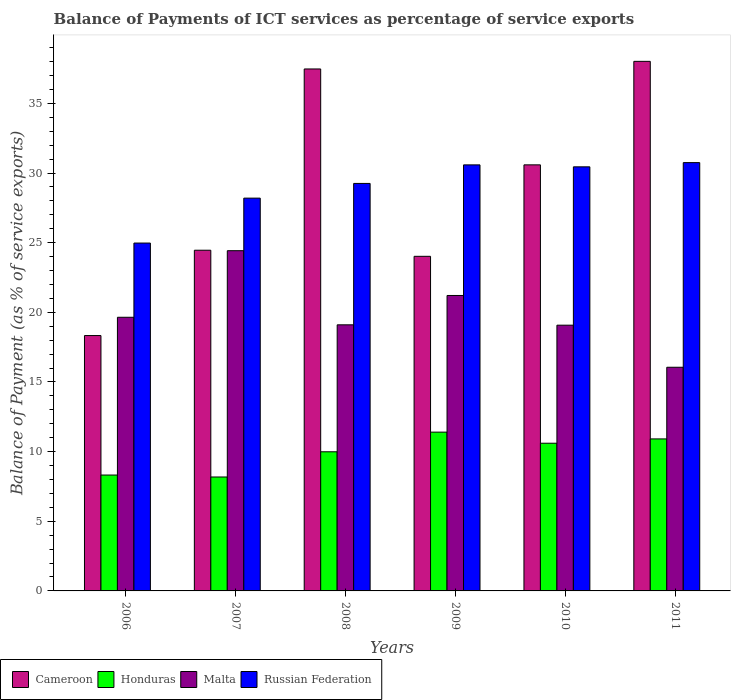How many different coloured bars are there?
Ensure brevity in your answer.  4. How many groups of bars are there?
Your answer should be compact. 6. Are the number of bars per tick equal to the number of legend labels?
Ensure brevity in your answer.  Yes. Are the number of bars on each tick of the X-axis equal?
Keep it short and to the point. Yes. How many bars are there on the 5th tick from the left?
Provide a short and direct response. 4. What is the label of the 1st group of bars from the left?
Make the answer very short. 2006. In how many cases, is the number of bars for a given year not equal to the number of legend labels?
Your answer should be very brief. 0. What is the balance of payments of ICT services in Malta in 2010?
Provide a short and direct response. 19.08. Across all years, what is the maximum balance of payments of ICT services in Cameroon?
Keep it short and to the point. 38.01. Across all years, what is the minimum balance of payments of ICT services in Honduras?
Keep it short and to the point. 8.18. In which year was the balance of payments of ICT services in Russian Federation maximum?
Your response must be concise. 2011. In which year was the balance of payments of ICT services in Malta minimum?
Give a very brief answer. 2011. What is the total balance of payments of ICT services in Malta in the graph?
Offer a terse response. 119.51. What is the difference between the balance of payments of ICT services in Honduras in 2006 and that in 2007?
Your answer should be compact. 0.14. What is the difference between the balance of payments of ICT services in Cameroon in 2011 and the balance of payments of ICT services in Russian Federation in 2009?
Provide a succinct answer. 7.43. What is the average balance of payments of ICT services in Russian Federation per year?
Provide a short and direct response. 29.03. In the year 2011, what is the difference between the balance of payments of ICT services in Malta and balance of payments of ICT services in Russian Federation?
Your response must be concise. -14.69. What is the ratio of the balance of payments of ICT services in Cameroon in 2009 to that in 2011?
Offer a terse response. 0.63. What is the difference between the highest and the second highest balance of payments of ICT services in Cameroon?
Your response must be concise. 0.55. What is the difference between the highest and the lowest balance of payments of ICT services in Honduras?
Give a very brief answer. 3.22. Is the sum of the balance of payments of ICT services in Russian Federation in 2007 and 2011 greater than the maximum balance of payments of ICT services in Honduras across all years?
Give a very brief answer. Yes. What does the 4th bar from the left in 2006 represents?
Your answer should be compact. Russian Federation. What does the 2nd bar from the right in 2008 represents?
Make the answer very short. Malta. Is it the case that in every year, the sum of the balance of payments of ICT services in Russian Federation and balance of payments of ICT services in Malta is greater than the balance of payments of ICT services in Honduras?
Offer a very short reply. Yes. How many bars are there?
Ensure brevity in your answer.  24. Are all the bars in the graph horizontal?
Your answer should be very brief. No. How many years are there in the graph?
Keep it short and to the point. 6. Does the graph contain any zero values?
Provide a short and direct response. No. How many legend labels are there?
Ensure brevity in your answer.  4. How are the legend labels stacked?
Provide a short and direct response. Horizontal. What is the title of the graph?
Provide a short and direct response. Balance of Payments of ICT services as percentage of service exports. Does "Timor-Leste" appear as one of the legend labels in the graph?
Ensure brevity in your answer.  No. What is the label or title of the X-axis?
Offer a terse response. Years. What is the label or title of the Y-axis?
Your answer should be compact. Balance of Payment (as % of service exports). What is the Balance of Payment (as % of service exports) in Cameroon in 2006?
Keep it short and to the point. 18.33. What is the Balance of Payment (as % of service exports) in Honduras in 2006?
Your answer should be compact. 8.32. What is the Balance of Payment (as % of service exports) in Malta in 2006?
Provide a succinct answer. 19.64. What is the Balance of Payment (as % of service exports) of Russian Federation in 2006?
Your response must be concise. 24.97. What is the Balance of Payment (as % of service exports) in Cameroon in 2007?
Offer a terse response. 24.46. What is the Balance of Payment (as % of service exports) in Honduras in 2007?
Your answer should be very brief. 8.18. What is the Balance of Payment (as % of service exports) of Malta in 2007?
Your answer should be compact. 24.42. What is the Balance of Payment (as % of service exports) of Russian Federation in 2007?
Provide a succinct answer. 28.2. What is the Balance of Payment (as % of service exports) in Cameroon in 2008?
Provide a succinct answer. 37.47. What is the Balance of Payment (as % of service exports) of Honduras in 2008?
Provide a succinct answer. 9.99. What is the Balance of Payment (as % of service exports) in Malta in 2008?
Give a very brief answer. 19.1. What is the Balance of Payment (as % of service exports) of Russian Federation in 2008?
Keep it short and to the point. 29.25. What is the Balance of Payment (as % of service exports) of Cameroon in 2009?
Offer a very short reply. 24.02. What is the Balance of Payment (as % of service exports) of Honduras in 2009?
Ensure brevity in your answer.  11.4. What is the Balance of Payment (as % of service exports) of Malta in 2009?
Your answer should be compact. 21.21. What is the Balance of Payment (as % of service exports) of Russian Federation in 2009?
Your answer should be compact. 30.58. What is the Balance of Payment (as % of service exports) of Cameroon in 2010?
Ensure brevity in your answer.  30.58. What is the Balance of Payment (as % of service exports) in Honduras in 2010?
Offer a terse response. 10.6. What is the Balance of Payment (as % of service exports) of Malta in 2010?
Ensure brevity in your answer.  19.08. What is the Balance of Payment (as % of service exports) in Russian Federation in 2010?
Offer a very short reply. 30.44. What is the Balance of Payment (as % of service exports) of Cameroon in 2011?
Provide a succinct answer. 38.01. What is the Balance of Payment (as % of service exports) in Honduras in 2011?
Offer a terse response. 10.91. What is the Balance of Payment (as % of service exports) in Malta in 2011?
Offer a very short reply. 16.06. What is the Balance of Payment (as % of service exports) of Russian Federation in 2011?
Your answer should be very brief. 30.74. Across all years, what is the maximum Balance of Payment (as % of service exports) of Cameroon?
Provide a short and direct response. 38.01. Across all years, what is the maximum Balance of Payment (as % of service exports) in Honduras?
Offer a terse response. 11.4. Across all years, what is the maximum Balance of Payment (as % of service exports) in Malta?
Provide a succinct answer. 24.42. Across all years, what is the maximum Balance of Payment (as % of service exports) in Russian Federation?
Your response must be concise. 30.74. Across all years, what is the minimum Balance of Payment (as % of service exports) of Cameroon?
Your response must be concise. 18.33. Across all years, what is the minimum Balance of Payment (as % of service exports) in Honduras?
Ensure brevity in your answer.  8.18. Across all years, what is the minimum Balance of Payment (as % of service exports) of Malta?
Your answer should be very brief. 16.06. Across all years, what is the minimum Balance of Payment (as % of service exports) in Russian Federation?
Your answer should be compact. 24.97. What is the total Balance of Payment (as % of service exports) of Cameroon in the graph?
Provide a short and direct response. 172.87. What is the total Balance of Payment (as % of service exports) in Honduras in the graph?
Make the answer very short. 59.4. What is the total Balance of Payment (as % of service exports) in Malta in the graph?
Your answer should be compact. 119.51. What is the total Balance of Payment (as % of service exports) of Russian Federation in the graph?
Give a very brief answer. 174.19. What is the difference between the Balance of Payment (as % of service exports) of Cameroon in 2006 and that in 2007?
Provide a short and direct response. -6.13. What is the difference between the Balance of Payment (as % of service exports) of Honduras in 2006 and that in 2007?
Provide a succinct answer. 0.14. What is the difference between the Balance of Payment (as % of service exports) of Malta in 2006 and that in 2007?
Your response must be concise. -4.78. What is the difference between the Balance of Payment (as % of service exports) of Russian Federation in 2006 and that in 2007?
Make the answer very short. -3.23. What is the difference between the Balance of Payment (as % of service exports) in Cameroon in 2006 and that in 2008?
Your answer should be very brief. -19.14. What is the difference between the Balance of Payment (as % of service exports) of Honduras in 2006 and that in 2008?
Offer a very short reply. -1.67. What is the difference between the Balance of Payment (as % of service exports) of Malta in 2006 and that in 2008?
Your response must be concise. 0.54. What is the difference between the Balance of Payment (as % of service exports) of Russian Federation in 2006 and that in 2008?
Give a very brief answer. -4.28. What is the difference between the Balance of Payment (as % of service exports) in Cameroon in 2006 and that in 2009?
Offer a terse response. -5.69. What is the difference between the Balance of Payment (as % of service exports) of Honduras in 2006 and that in 2009?
Your response must be concise. -3.08. What is the difference between the Balance of Payment (as % of service exports) of Malta in 2006 and that in 2009?
Offer a terse response. -1.56. What is the difference between the Balance of Payment (as % of service exports) in Russian Federation in 2006 and that in 2009?
Provide a short and direct response. -5.61. What is the difference between the Balance of Payment (as % of service exports) in Cameroon in 2006 and that in 2010?
Offer a very short reply. -12.25. What is the difference between the Balance of Payment (as % of service exports) in Honduras in 2006 and that in 2010?
Offer a very short reply. -2.28. What is the difference between the Balance of Payment (as % of service exports) of Malta in 2006 and that in 2010?
Give a very brief answer. 0.57. What is the difference between the Balance of Payment (as % of service exports) in Russian Federation in 2006 and that in 2010?
Offer a very short reply. -5.47. What is the difference between the Balance of Payment (as % of service exports) of Cameroon in 2006 and that in 2011?
Give a very brief answer. -19.68. What is the difference between the Balance of Payment (as % of service exports) of Honduras in 2006 and that in 2011?
Offer a terse response. -2.59. What is the difference between the Balance of Payment (as % of service exports) of Malta in 2006 and that in 2011?
Keep it short and to the point. 3.59. What is the difference between the Balance of Payment (as % of service exports) of Russian Federation in 2006 and that in 2011?
Offer a terse response. -5.77. What is the difference between the Balance of Payment (as % of service exports) in Cameroon in 2007 and that in 2008?
Give a very brief answer. -13.01. What is the difference between the Balance of Payment (as % of service exports) of Honduras in 2007 and that in 2008?
Provide a succinct answer. -1.81. What is the difference between the Balance of Payment (as % of service exports) in Malta in 2007 and that in 2008?
Your response must be concise. 5.32. What is the difference between the Balance of Payment (as % of service exports) of Russian Federation in 2007 and that in 2008?
Provide a succinct answer. -1.06. What is the difference between the Balance of Payment (as % of service exports) in Cameroon in 2007 and that in 2009?
Your answer should be very brief. 0.44. What is the difference between the Balance of Payment (as % of service exports) of Honduras in 2007 and that in 2009?
Offer a terse response. -3.22. What is the difference between the Balance of Payment (as % of service exports) of Malta in 2007 and that in 2009?
Your answer should be compact. 3.21. What is the difference between the Balance of Payment (as % of service exports) in Russian Federation in 2007 and that in 2009?
Your response must be concise. -2.39. What is the difference between the Balance of Payment (as % of service exports) in Cameroon in 2007 and that in 2010?
Ensure brevity in your answer.  -6.13. What is the difference between the Balance of Payment (as % of service exports) in Honduras in 2007 and that in 2010?
Make the answer very short. -2.42. What is the difference between the Balance of Payment (as % of service exports) of Malta in 2007 and that in 2010?
Your answer should be compact. 5.35. What is the difference between the Balance of Payment (as % of service exports) in Russian Federation in 2007 and that in 2010?
Provide a short and direct response. -2.25. What is the difference between the Balance of Payment (as % of service exports) of Cameroon in 2007 and that in 2011?
Your response must be concise. -13.56. What is the difference between the Balance of Payment (as % of service exports) in Honduras in 2007 and that in 2011?
Your response must be concise. -2.73. What is the difference between the Balance of Payment (as % of service exports) in Malta in 2007 and that in 2011?
Your answer should be compact. 8.37. What is the difference between the Balance of Payment (as % of service exports) in Russian Federation in 2007 and that in 2011?
Ensure brevity in your answer.  -2.55. What is the difference between the Balance of Payment (as % of service exports) of Cameroon in 2008 and that in 2009?
Keep it short and to the point. 13.45. What is the difference between the Balance of Payment (as % of service exports) in Honduras in 2008 and that in 2009?
Your answer should be very brief. -1.41. What is the difference between the Balance of Payment (as % of service exports) of Malta in 2008 and that in 2009?
Provide a succinct answer. -2.11. What is the difference between the Balance of Payment (as % of service exports) in Russian Federation in 2008 and that in 2009?
Provide a succinct answer. -1.33. What is the difference between the Balance of Payment (as % of service exports) in Cameroon in 2008 and that in 2010?
Your response must be concise. 6.88. What is the difference between the Balance of Payment (as % of service exports) of Honduras in 2008 and that in 2010?
Ensure brevity in your answer.  -0.61. What is the difference between the Balance of Payment (as % of service exports) in Malta in 2008 and that in 2010?
Provide a short and direct response. 0.03. What is the difference between the Balance of Payment (as % of service exports) of Russian Federation in 2008 and that in 2010?
Your answer should be compact. -1.19. What is the difference between the Balance of Payment (as % of service exports) in Cameroon in 2008 and that in 2011?
Your answer should be very brief. -0.55. What is the difference between the Balance of Payment (as % of service exports) of Honduras in 2008 and that in 2011?
Keep it short and to the point. -0.92. What is the difference between the Balance of Payment (as % of service exports) in Malta in 2008 and that in 2011?
Offer a very short reply. 3.05. What is the difference between the Balance of Payment (as % of service exports) in Russian Federation in 2008 and that in 2011?
Provide a short and direct response. -1.49. What is the difference between the Balance of Payment (as % of service exports) in Cameroon in 2009 and that in 2010?
Your answer should be very brief. -6.57. What is the difference between the Balance of Payment (as % of service exports) in Honduras in 2009 and that in 2010?
Your answer should be very brief. 0.8. What is the difference between the Balance of Payment (as % of service exports) in Malta in 2009 and that in 2010?
Make the answer very short. 2.13. What is the difference between the Balance of Payment (as % of service exports) in Russian Federation in 2009 and that in 2010?
Keep it short and to the point. 0.14. What is the difference between the Balance of Payment (as % of service exports) in Cameroon in 2009 and that in 2011?
Provide a succinct answer. -14. What is the difference between the Balance of Payment (as % of service exports) of Honduras in 2009 and that in 2011?
Keep it short and to the point. 0.49. What is the difference between the Balance of Payment (as % of service exports) in Malta in 2009 and that in 2011?
Your answer should be compact. 5.15. What is the difference between the Balance of Payment (as % of service exports) in Russian Federation in 2009 and that in 2011?
Offer a very short reply. -0.16. What is the difference between the Balance of Payment (as % of service exports) in Cameroon in 2010 and that in 2011?
Make the answer very short. -7.43. What is the difference between the Balance of Payment (as % of service exports) of Honduras in 2010 and that in 2011?
Offer a very short reply. -0.31. What is the difference between the Balance of Payment (as % of service exports) in Malta in 2010 and that in 2011?
Provide a short and direct response. 3.02. What is the difference between the Balance of Payment (as % of service exports) of Russian Federation in 2010 and that in 2011?
Ensure brevity in your answer.  -0.3. What is the difference between the Balance of Payment (as % of service exports) in Cameroon in 2006 and the Balance of Payment (as % of service exports) in Honduras in 2007?
Your answer should be very brief. 10.15. What is the difference between the Balance of Payment (as % of service exports) in Cameroon in 2006 and the Balance of Payment (as % of service exports) in Malta in 2007?
Your response must be concise. -6.09. What is the difference between the Balance of Payment (as % of service exports) of Cameroon in 2006 and the Balance of Payment (as % of service exports) of Russian Federation in 2007?
Give a very brief answer. -9.86. What is the difference between the Balance of Payment (as % of service exports) in Honduras in 2006 and the Balance of Payment (as % of service exports) in Malta in 2007?
Provide a succinct answer. -16.1. What is the difference between the Balance of Payment (as % of service exports) in Honduras in 2006 and the Balance of Payment (as % of service exports) in Russian Federation in 2007?
Give a very brief answer. -19.88. What is the difference between the Balance of Payment (as % of service exports) in Malta in 2006 and the Balance of Payment (as % of service exports) in Russian Federation in 2007?
Offer a terse response. -8.55. What is the difference between the Balance of Payment (as % of service exports) in Cameroon in 2006 and the Balance of Payment (as % of service exports) in Honduras in 2008?
Your answer should be compact. 8.34. What is the difference between the Balance of Payment (as % of service exports) of Cameroon in 2006 and the Balance of Payment (as % of service exports) of Malta in 2008?
Offer a very short reply. -0.77. What is the difference between the Balance of Payment (as % of service exports) in Cameroon in 2006 and the Balance of Payment (as % of service exports) in Russian Federation in 2008?
Offer a terse response. -10.92. What is the difference between the Balance of Payment (as % of service exports) in Honduras in 2006 and the Balance of Payment (as % of service exports) in Malta in 2008?
Offer a terse response. -10.78. What is the difference between the Balance of Payment (as % of service exports) of Honduras in 2006 and the Balance of Payment (as % of service exports) of Russian Federation in 2008?
Provide a short and direct response. -20.93. What is the difference between the Balance of Payment (as % of service exports) in Malta in 2006 and the Balance of Payment (as % of service exports) in Russian Federation in 2008?
Offer a terse response. -9.61. What is the difference between the Balance of Payment (as % of service exports) in Cameroon in 2006 and the Balance of Payment (as % of service exports) in Honduras in 2009?
Provide a short and direct response. 6.93. What is the difference between the Balance of Payment (as % of service exports) in Cameroon in 2006 and the Balance of Payment (as % of service exports) in Malta in 2009?
Keep it short and to the point. -2.88. What is the difference between the Balance of Payment (as % of service exports) in Cameroon in 2006 and the Balance of Payment (as % of service exports) in Russian Federation in 2009?
Your response must be concise. -12.25. What is the difference between the Balance of Payment (as % of service exports) in Honduras in 2006 and the Balance of Payment (as % of service exports) in Malta in 2009?
Your response must be concise. -12.89. What is the difference between the Balance of Payment (as % of service exports) of Honduras in 2006 and the Balance of Payment (as % of service exports) of Russian Federation in 2009?
Provide a succinct answer. -22.27. What is the difference between the Balance of Payment (as % of service exports) of Malta in 2006 and the Balance of Payment (as % of service exports) of Russian Federation in 2009?
Your answer should be compact. -10.94. What is the difference between the Balance of Payment (as % of service exports) in Cameroon in 2006 and the Balance of Payment (as % of service exports) in Honduras in 2010?
Your answer should be compact. 7.73. What is the difference between the Balance of Payment (as % of service exports) in Cameroon in 2006 and the Balance of Payment (as % of service exports) in Malta in 2010?
Make the answer very short. -0.75. What is the difference between the Balance of Payment (as % of service exports) in Cameroon in 2006 and the Balance of Payment (as % of service exports) in Russian Federation in 2010?
Ensure brevity in your answer.  -12.11. What is the difference between the Balance of Payment (as % of service exports) in Honduras in 2006 and the Balance of Payment (as % of service exports) in Malta in 2010?
Make the answer very short. -10.76. What is the difference between the Balance of Payment (as % of service exports) in Honduras in 2006 and the Balance of Payment (as % of service exports) in Russian Federation in 2010?
Make the answer very short. -22.12. What is the difference between the Balance of Payment (as % of service exports) in Malta in 2006 and the Balance of Payment (as % of service exports) in Russian Federation in 2010?
Provide a short and direct response. -10.8. What is the difference between the Balance of Payment (as % of service exports) of Cameroon in 2006 and the Balance of Payment (as % of service exports) of Honduras in 2011?
Offer a terse response. 7.42. What is the difference between the Balance of Payment (as % of service exports) of Cameroon in 2006 and the Balance of Payment (as % of service exports) of Malta in 2011?
Ensure brevity in your answer.  2.28. What is the difference between the Balance of Payment (as % of service exports) in Cameroon in 2006 and the Balance of Payment (as % of service exports) in Russian Federation in 2011?
Provide a succinct answer. -12.41. What is the difference between the Balance of Payment (as % of service exports) of Honduras in 2006 and the Balance of Payment (as % of service exports) of Malta in 2011?
Offer a very short reply. -7.74. What is the difference between the Balance of Payment (as % of service exports) of Honduras in 2006 and the Balance of Payment (as % of service exports) of Russian Federation in 2011?
Offer a terse response. -22.43. What is the difference between the Balance of Payment (as % of service exports) in Malta in 2006 and the Balance of Payment (as % of service exports) in Russian Federation in 2011?
Offer a terse response. -11.1. What is the difference between the Balance of Payment (as % of service exports) of Cameroon in 2007 and the Balance of Payment (as % of service exports) of Honduras in 2008?
Give a very brief answer. 14.47. What is the difference between the Balance of Payment (as % of service exports) in Cameroon in 2007 and the Balance of Payment (as % of service exports) in Malta in 2008?
Provide a short and direct response. 5.35. What is the difference between the Balance of Payment (as % of service exports) of Cameroon in 2007 and the Balance of Payment (as % of service exports) of Russian Federation in 2008?
Ensure brevity in your answer.  -4.79. What is the difference between the Balance of Payment (as % of service exports) of Honduras in 2007 and the Balance of Payment (as % of service exports) of Malta in 2008?
Ensure brevity in your answer.  -10.92. What is the difference between the Balance of Payment (as % of service exports) of Honduras in 2007 and the Balance of Payment (as % of service exports) of Russian Federation in 2008?
Offer a very short reply. -21.07. What is the difference between the Balance of Payment (as % of service exports) of Malta in 2007 and the Balance of Payment (as % of service exports) of Russian Federation in 2008?
Your answer should be compact. -4.83. What is the difference between the Balance of Payment (as % of service exports) in Cameroon in 2007 and the Balance of Payment (as % of service exports) in Honduras in 2009?
Your response must be concise. 13.06. What is the difference between the Balance of Payment (as % of service exports) in Cameroon in 2007 and the Balance of Payment (as % of service exports) in Malta in 2009?
Keep it short and to the point. 3.25. What is the difference between the Balance of Payment (as % of service exports) in Cameroon in 2007 and the Balance of Payment (as % of service exports) in Russian Federation in 2009?
Your answer should be compact. -6.13. What is the difference between the Balance of Payment (as % of service exports) of Honduras in 2007 and the Balance of Payment (as % of service exports) of Malta in 2009?
Provide a short and direct response. -13.03. What is the difference between the Balance of Payment (as % of service exports) of Honduras in 2007 and the Balance of Payment (as % of service exports) of Russian Federation in 2009?
Your answer should be very brief. -22.41. What is the difference between the Balance of Payment (as % of service exports) of Malta in 2007 and the Balance of Payment (as % of service exports) of Russian Federation in 2009?
Your response must be concise. -6.16. What is the difference between the Balance of Payment (as % of service exports) in Cameroon in 2007 and the Balance of Payment (as % of service exports) in Honduras in 2010?
Keep it short and to the point. 13.85. What is the difference between the Balance of Payment (as % of service exports) of Cameroon in 2007 and the Balance of Payment (as % of service exports) of Malta in 2010?
Ensure brevity in your answer.  5.38. What is the difference between the Balance of Payment (as % of service exports) in Cameroon in 2007 and the Balance of Payment (as % of service exports) in Russian Federation in 2010?
Offer a very short reply. -5.99. What is the difference between the Balance of Payment (as % of service exports) of Honduras in 2007 and the Balance of Payment (as % of service exports) of Malta in 2010?
Give a very brief answer. -10.9. What is the difference between the Balance of Payment (as % of service exports) in Honduras in 2007 and the Balance of Payment (as % of service exports) in Russian Federation in 2010?
Offer a very short reply. -22.26. What is the difference between the Balance of Payment (as % of service exports) of Malta in 2007 and the Balance of Payment (as % of service exports) of Russian Federation in 2010?
Provide a succinct answer. -6.02. What is the difference between the Balance of Payment (as % of service exports) of Cameroon in 2007 and the Balance of Payment (as % of service exports) of Honduras in 2011?
Make the answer very short. 13.54. What is the difference between the Balance of Payment (as % of service exports) in Cameroon in 2007 and the Balance of Payment (as % of service exports) in Malta in 2011?
Give a very brief answer. 8.4. What is the difference between the Balance of Payment (as % of service exports) of Cameroon in 2007 and the Balance of Payment (as % of service exports) of Russian Federation in 2011?
Provide a short and direct response. -6.29. What is the difference between the Balance of Payment (as % of service exports) in Honduras in 2007 and the Balance of Payment (as % of service exports) in Malta in 2011?
Keep it short and to the point. -7.88. What is the difference between the Balance of Payment (as % of service exports) in Honduras in 2007 and the Balance of Payment (as % of service exports) in Russian Federation in 2011?
Your answer should be very brief. -22.57. What is the difference between the Balance of Payment (as % of service exports) of Malta in 2007 and the Balance of Payment (as % of service exports) of Russian Federation in 2011?
Provide a short and direct response. -6.32. What is the difference between the Balance of Payment (as % of service exports) of Cameroon in 2008 and the Balance of Payment (as % of service exports) of Honduras in 2009?
Keep it short and to the point. 26.07. What is the difference between the Balance of Payment (as % of service exports) of Cameroon in 2008 and the Balance of Payment (as % of service exports) of Malta in 2009?
Keep it short and to the point. 16.26. What is the difference between the Balance of Payment (as % of service exports) of Cameroon in 2008 and the Balance of Payment (as % of service exports) of Russian Federation in 2009?
Offer a terse response. 6.89. What is the difference between the Balance of Payment (as % of service exports) of Honduras in 2008 and the Balance of Payment (as % of service exports) of Malta in 2009?
Provide a short and direct response. -11.22. What is the difference between the Balance of Payment (as % of service exports) in Honduras in 2008 and the Balance of Payment (as % of service exports) in Russian Federation in 2009?
Provide a succinct answer. -20.6. What is the difference between the Balance of Payment (as % of service exports) of Malta in 2008 and the Balance of Payment (as % of service exports) of Russian Federation in 2009?
Provide a succinct answer. -11.48. What is the difference between the Balance of Payment (as % of service exports) of Cameroon in 2008 and the Balance of Payment (as % of service exports) of Honduras in 2010?
Offer a very short reply. 26.87. What is the difference between the Balance of Payment (as % of service exports) in Cameroon in 2008 and the Balance of Payment (as % of service exports) in Malta in 2010?
Keep it short and to the point. 18.39. What is the difference between the Balance of Payment (as % of service exports) in Cameroon in 2008 and the Balance of Payment (as % of service exports) in Russian Federation in 2010?
Provide a short and direct response. 7.03. What is the difference between the Balance of Payment (as % of service exports) of Honduras in 2008 and the Balance of Payment (as % of service exports) of Malta in 2010?
Provide a succinct answer. -9.09. What is the difference between the Balance of Payment (as % of service exports) in Honduras in 2008 and the Balance of Payment (as % of service exports) in Russian Federation in 2010?
Keep it short and to the point. -20.46. What is the difference between the Balance of Payment (as % of service exports) of Malta in 2008 and the Balance of Payment (as % of service exports) of Russian Federation in 2010?
Provide a short and direct response. -11.34. What is the difference between the Balance of Payment (as % of service exports) of Cameroon in 2008 and the Balance of Payment (as % of service exports) of Honduras in 2011?
Your response must be concise. 26.56. What is the difference between the Balance of Payment (as % of service exports) in Cameroon in 2008 and the Balance of Payment (as % of service exports) in Malta in 2011?
Give a very brief answer. 21.41. What is the difference between the Balance of Payment (as % of service exports) in Cameroon in 2008 and the Balance of Payment (as % of service exports) in Russian Federation in 2011?
Provide a succinct answer. 6.72. What is the difference between the Balance of Payment (as % of service exports) in Honduras in 2008 and the Balance of Payment (as % of service exports) in Malta in 2011?
Offer a terse response. -6.07. What is the difference between the Balance of Payment (as % of service exports) of Honduras in 2008 and the Balance of Payment (as % of service exports) of Russian Federation in 2011?
Your answer should be very brief. -20.76. What is the difference between the Balance of Payment (as % of service exports) of Malta in 2008 and the Balance of Payment (as % of service exports) of Russian Federation in 2011?
Your answer should be compact. -11.64. What is the difference between the Balance of Payment (as % of service exports) in Cameroon in 2009 and the Balance of Payment (as % of service exports) in Honduras in 2010?
Your answer should be very brief. 13.42. What is the difference between the Balance of Payment (as % of service exports) of Cameroon in 2009 and the Balance of Payment (as % of service exports) of Malta in 2010?
Your answer should be very brief. 4.94. What is the difference between the Balance of Payment (as % of service exports) of Cameroon in 2009 and the Balance of Payment (as % of service exports) of Russian Federation in 2010?
Offer a very short reply. -6.42. What is the difference between the Balance of Payment (as % of service exports) of Honduras in 2009 and the Balance of Payment (as % of service exports) of Malta in 2010?
Provide a succinct answer. -7.68. What is the difference between the Balance of Payment (as % of service exports) of Honduras in 2009 and the Balance of Payment (as % of service exports) of Russian Federation in 2010?
Your answer should be compact. -19.04. What is the difference between the Balance of Payment (as % of service exports) of Malta in 2009 and the Balance of Payment (as % of service exports) of Russian Federation in 2010?
Provide a short and direct response. -9.23. What is the difference between the Balance of Payment (as % of service exports) of Cameroon in 2009 and the Balance of Payment (as % of service exports) of Honduras in 2011?
Provide a short and direct response. 13.11. What is the difference between the Balance of Payment (as % of service exports) in Cameroon in 2009 and the Balance of Payment (as % of service exports) in Malta in 2011?
Provide a succinct answer. 7.96. What is the difference between the Balance of Payment (as % of service exports) of Cameroon in 2009 and the Balance of Payment (as % of service exports) of Russian Federation in 2011?
Your response must be concise. -6.73. What is the difference between the Balance of Payment (as % of service exports) in Honduras in 2009 and the Balance of Payment (as % of service exports) in Malta in 2011?
Give a very brief answer. -4.66. What is the difference between the Balance of Payment (as % of service exports) in Honduras in 2009 and the Balance of Payment (as % of service exports) in Russian Federation in 2011?
Provide a short and direct response. -19.35. What is the difference between the Balance of Payment (as % of service exports) of Malta in 2009 and the Balance of Payment (as % of service exports) of Russian Federation in 2011?
Offer a terse response. -9.54. What is the difference between the Balance of Payment (as % of service exports) of Cameroon in 2010 and the Balance of Payment (as % of service exports) of Honduras in 2011?
Your answer should be compact. 19.67. What is the difference between the Balance of Payment (as % of service exports) of Cameroon in 2010 and the Balance of Payment (as % of service exports) of Malta in 2011?
Your answer should be compact. 14.53. What is the difference between the Balance of Payment (as % of service exports) of Cameroon in 2010 and the Balance of Payment (as % of service exports) of Russian Federation in 2011?
Your answer should be compact. -0.16. What is the difference between the Balance of Payment (as % of service exports) in Honduras in 2010 and the Balance of Payment (as % of service exports) in Malta in 2011?
Give a very brief answer. -5.45. What is the difference between the Balance of Payment (as % of service exports) in Honduras in 2010 and the Balance of Payment (as % of service exports) in Russian Federation in 2011?
Ensure brevity in your answer.  -20.14. What is the difference between the Balance of Payment (as % of service exports) in Malta in 2010 and the Balance of Payment (as % of service exports) in Russian Federation in 2011?
Your answer should be very brief. -11.67. What is the average Balance of Payment (as % of service exports) of Cameroon per year?
Ensure brevity in your answer.  28.81. What is the average Balance of Payment (as % of service exports) of Honduras per year?
Provide a short and direct response. 9.9. What is the average Balance of Payment (as % of service exports) of Malta per year?
Keep it short and to the point. 19.92. What is the average Balance of Payment (as % of service exports) of Russian Federation per year?
Your answer should be compact. 29.03. In the year 2006, what is the difference between the Balance of Payment (as % of service exports) in Cameroon and Balance of Payment (as % of service exports) in Honduras?
Offer a very short reply. 10.01. In the year 2006, what is the difference between the Balance of Payment (as % of service exports) in Cameroon and Balance of Payment (as % of service exports) in Malta?
Your answer should be very brief. -1.31. In the year 2006, what is the difference between the Balance of Payment (as % of service exports) in Cameroon and Balance of Payment (as % of service exports) in Russian Federation?
Offer a terse response. -6.64. In the year 2006, what is the difference between the Balance of Payment (as % of service exports) in Honduras and Balance of Payment (as % of service exports) in Malta?
Offer a terse response. -11.33. In the year 2006, what is the difference between the Balance of Payment (as % of service exports) of Honduras and Balance of Payment (as % of service exports) of Russian Federation?
Your answer should be compact. -16.65. In the year 2006, what is the difference between the Balance of Payment (as % of service exports) of Malta and Balance of Payment (as % of service exports) of Russian Federation?
Your response must be concise. -5.33. In the year 2007, what is the difference between the Balance of Payment (as % of service exports) in Cameroon and Balance of Payment (as % of service exports) in Honduras?
Offer a very short reply. 16.28. In the year 2007, what is the difference between the Balance of Payment (as % of service exports) in Cameroon and Balance of Payment (as % of service exports) in Malta?
Offer a terse response. 0.03. In the year 2007, what is the difference between the Balance of Payment (as % of service exports) in Cameroon and Balance of Payment (as % of service exports) in Russian Federation?
Make the answer very short. -3.74. In the year 2007, what is the difference between the Balance of Payment (as % of service exports) of Honduras and Balance of Payment (as % of service exports) of Malta?
Offer a terse response. -16.24. In the year 2007, what is the difference between the Balance of Payment (as % of service exports) of Honduras and Balance of Payment (as % of service exports) of Russian Federation?
Your answer should be compact. -20.02. In the year 2007, what is the difference between the Balance of Payment (as % of service exports) of Malta and Balance of Payment (as % of service exports) of Russian Federation?
Ensure brevity in your answer.  -3.77. In the year 2008, what is the difference between the Balance of Payment (as % of service exports) of Cameroon and Balance of Payment (as % of service exports) of Honduras?
Provide a succinct answer. 27.48. In the year 2008, what is the difference between the Balance of Payment (as % of service exports) of Cameroon and Balance of Payment (as % of service exports) of Malta?
Your response must be concise. 18.37. In the year 2008, what is the difference between the Balance of Payment (as % of service exports) in Cameroon and Balance of Payment (as % of service exports) in Russian Federation?
Give a very brief answer. 8.22. In the year 2008, what is the difference between the Balance of Payment (as % of service exports) of Honduras and Balance of Payment (as % of service exports) of Malta?
Offer a terse response. -9.11. In the year 2008, what is the difference between the Balance of Payment (as % of service exports) of Honduras and Balance of Payment (as % of service exports) of Russian Federation?
Offer a terse response. -19.26. In the year 2008, what is the difference between the Balance of Payment (as % of service exports) of Malta and Balance of Payment (as % of service exports) of Russian Federation?
Offer a terse response. -10.15. In the year 2009, what is the difference between the Balance of Payment (as % of service exports) in Cameroon and Balance of Payment (as % of service exports) in Honduras?
Your response must be concise. 12.62. In the year 2009, what is the difference between the Balance of Payment (as % of service exports) of Cameroon and Balance of Payment (as % of service exports) of Malta?
Offer a terse response. 2.81. In the year 2009, what is the difference between the Balance of Payment (as % of service exports) of Cameroon and Balance of Payment (as % of service exports) of Russian Federation?
Give a very brief answer. -6.56. In the year 2009, what is the difference between the Balance of Payment (as % of service exports) of Honduras and Balance of Payment (as % of service exports) of Malta?
Your answer should be compact. -9.81. In the year 2009, what is the difference between the Balance of Payment (as % of service exports) of Honduras and Balance of Payment (as % of service exports) of Russian Federation?
Offer a terse response. -19.19. In the year 2009, what is the difference between the Balance of Payment (as % of service exports) in Malta and Balance of Payment (as % of service exports) in Russian Federation?
Provide a succinct answer. -9.38. In the year 2010, what is the difference between the Balance of Payment (as % of service exports) in Cameroon and Balance of Payment (as % of service exports) in Honduras?
Provide a short and direct response. 19.98. In the year 2010, what is the difference between the Balance of Payment (as % of service exports) of Cameroon and Balance of Payment (as % of service exports) of Malta?
Your answer should be compact. 11.51. In the year 2010, what is the difference between the Balance of Payment (as % of service exports) of Cameroon and Balance of Payment (as % of service exports) of Russian Federation?
Provide a short and direct response. 0.14. In the year 2010, what is the difference between the Balance of Payment (as % of service exports) of Honduras and Balance of Payment (as % of service exports) of Malta?
Ensure brevity in your answer.  -8.47. In the year 2010, what is the difference between the Balance of Payment (as % of service exports) of Honduras and Balance of Payment (as % of service exports) of Russian Federation?
Your answer should be compact. -19.84. In the year 2010, what is the difference between the Balance of Payment (as % of service exports) of Malta and Balance of Payment (as % of service exports) of Russian Federation?
Ensure brevity in your answer.  -11.37. In the year 2011, what is the difference between the Balance of Payment (as % of service exports) of Cameroon and Balance of Payment (as % of service exports) of Honduras?
Offer a terse response. 27.1. In the year 2011, what is the difference between the Balance of Payment (as % of service exports) in Cameroon and Balance of Payment (as % of service exports) in Malta?
Keep it short and to the point. 21.96. In the year 2011, what is the difference between the Balance of Payment (as % of service exports) in Cameroon and Balance of Payment (as % of service exports) in Russian Federation?
Keep it short and to the point. 7.27. In the year 2011, what is the difference between the Balance of Payment (as % of service exports) in Honduras and Balance of Payment (as % of service exports) in Malta?
Offer a very short reply. -5.14. In the year 2011, what is the difference between the Balance of Payment (as % of service exports) in Honduras and Balance of Payment (as % of service exports) in Russian Federation?
Offer a terse response. -19.83. In the year 2011, what is the difference between the Balance of Payment (as % of service exports) of Malta and Balance of Payment (as % of service exports) of Russian Federation?
Offer a terse response. -14.69. What is the ratio of the Balance of Payment (as % of service exports) of Cameroon in 2006 to that in 2007?
Your response must be concise. 0.75. What is the ratio of the Balance of Payment (as % of service exports) in Honduras in 2006 to that in 2007?
Your response must be concise. 1.02. What is the ratio of the Balance of Payment (as % of service exports) of Malta in 2006 to that in 2007?
Ensure brevity in your answer.  0.8. What is the ratio of the Balance of Payment (as % of service exports) in Russian Federation in 2006 to that in 2007?
Your answer should be compact. 0.89. What is the ratio of the Balance of Payment (as % of service exports) of Cameroon in 2006 to that in 2008?
Your answer should be compact. 0.49. What is the ratio of the Balance of Payment (as % of service exports) of Honduras in 2006 to that in 2008?
Give a very brief answer. 0.83. What is the ratio of the Balance of Payment (as % of service exports) in Malta in 2006 to that in 2008?
Provide a succinct answer. 1.03. What is the ratio of the Balance of Payment (as % of service exports) in Russian Federation in 2006 to that in 2008?
Your answer should be very brief. 0.85. What is the ratio of the Balance of Payment (as % of service exports) in Cameroon in 2006 to that in 2009?
Your answer should be compact. 0.76. What is the ratio of the Balance of Payment (as % of service exports) in Honduras in 2006 to that in 2009?
Provide a succinct answer. 0.73. What is the ratio of the Balance of Payment (as % of service exports) in Malta in 2006 to that in 2009?
Give a very brief answer. 0.93. What is the ratio of the Balance of Payment (as % of service exports) in Russian Federation in 2006 to that in 2009?
Your answer should be compact. 0.82. What is the ratio of the Balance of Payment (as % of service exports) in Cameroon in 2006 to that in 2010?
Offer a terse response. 0.6. What is the ratio of the Balance of Payment (as % of service exports) in Honduras in 2006 to that in 2010?
Provide a succinct answer. 0.78. What is the ratio of the Balance of Payment (as % of service exports) of Malta in 2006 to that in 2010?
Keep it short and to the point. 1.03. What is the ratio of the Balance of Payment (as % of service exports) of Russian Federation in 2006 to that in 2010?
Give a very brief answer. 0.82. What is the ratio of the Balance of Payment (as % of service exports) in Cameroon in 2006 to that in 2011?
Provide a succinct answer. 0.48. What is the ratio of the Balance of Payment (as % of service exports) of Honduras in 2006 to that in 2011?
Provide a succinct answer. 0.76. What is the ratio of the Balance of Payment (as % of service exports) in Malta in 2006 to that in 2011?
Provide a succinct answer. 1.22. What is the ratio of the Balance of Payment (as % of service exports) in Russian Federation in 2006 to that in 2011?
Your answer should be very brief. 0.81. What is the ratio of the Balance of Payment (as % of service exports) of Cameroon in 2007 to that in 2008?
Give a very brief answer. 0.65. What is the ratio of the Balance of Payment (as % of service exports) of Honduras in 2007 to that in 2008?
Ensure brevity in your answer.  0.82. What is the ratio of the Balance of Payment (as % of service exports) in Malta in 2007 to that in 2008?
Your answer should be very brief. 1.28. What is the ratio of the Balance of Payment (as % of service exports) in Russian Federation in 2007 to that in 2008?
Keep it short and to the point. 0.96. What is the ratio of the Balance of Payment (as % of service exports) in Cameroon in 2007 to that in 2009?
Provide a short and direct response. 1.02. What is the ratio of the Balance of Payment (as % of service exports) of Honduras in 2007 to that in 2009?
Provide a short and direct response. 0.72. What is the ratio of the Balance of Payment (as % of service exports) of Malta in 2007 to that in 2009?
Make the answer very short. 1.15. What is the ratio of the Balance of Payment (as % of service exports) of Russian Federation in 2007 to that in 2009?
Your answer should be very brief. 0.92. What is the ratio of the Balance of Payment (as % of service exports) of Cameroon in 2007 to that in 2010?
Offer a terse response. 0.8. What is the ratio of the Balance of Payment (as % of service exports) of Honduras in 2007 to that in 2010?
Keep it short and to the point. 0.77. What is the ratio of the Balance of Payment (as % of service exports) of Malta in 2007 to that in 2010?
Offer a very short reply. 1.28. What is the ratio of the Balance of Payment (as % of service exports) in Russian Federation in 2007 to that in 2010?
Keep it short and to the point. 0.93. What is the ratio of the Balance of Payment (as % of service exports) in Cameroon in 2007 to that in 2011?
Provide a succinct answer. 0.64. What is the ratio of the Balance of Payment (as % of service exports) in Honduras in 2007 to that in 2011?
Make the answer very short. 0.75. What is the ratio of the Balance of Payment (as % of service exports) of Malta in 2007 to that in 2011?
Your response must be concise. 1.52. What is the ratio of the Balance of Payment (as % of service exports) of Russian Federation in 2007 to that in 2011?
Provide a succinct answer. 0.92. What is the ratio of the Balance of Payment (as % of service exports) of Cameroon in 2008 to that in 2009?
Make the answer very short. 1.56. What is the ratio of the Balance of Payment (as % of service exports) in Honduras in 2008 to that in 2009?
Offer a terse response. 0.88. What is the ratio of the Balance of Payment (as % of service exports) in Malta in 2008 to that in 2009?
Offer a very short reply. 0.9. What is the ratio of the Balance of Payment (as % of service exports) of Russian Federation in 2008 to that in 2009?
Make the answer very short. 0.96. What is the ratio of the Balance of Payment (as % of service exports) in Cameroon in 2008 to that in 2010?
Your response must be concise. 1.23. What is the ratio of the Balance of Payment (as % of service exports) in Honduras in 2008 to that in 2010?
Offer a terse response. 0.94. What is the ratio of the Balance of Payment (as % of service exports) of Russian Federation in 2008 to that in 2010?
Give a very brief answer. 0.96. What is the ratio of the Balance of Payment (as % of service exports) in Cameroon in 2008 to that in 2011?
Ensure brevity in your answer.  0.99. What is the ratio of the Balance of Payment (as % of service exports) in Honduras in 2008 to that in 2011?
Provide a succinct answer. 0.92. What is the ratio of the Balance of Payment (as % of service exports) of Malta in 2008 to that in 2011?
Provide a short and direct response. 1.19. What is the ratio of the Balance of Payment (as % of service exports) in Russian Federation in 2008 to that in 2011?
Ensure brevity in your answer.  0.95. What is the ratio of the Balance of Payment (as % of service exports) of Cameroon in 2009 to that in 2010?
Provide a short and direct response. 0.79. What is the ratio of the Balance of Payment (as % of service exports) in Honduras in 2009 to that in 2010?
Provide a short and direct response. 1.08. What is the ratio of the Balance of Payment (as % of service exports) of Malta in 2009 to that in 2010?
Keep it short and to the point. 1.11. What is the ratio of the Balance of Payment (as % of service exports) of Cameroon in 2009 to that in 2011?
Your response must be concise. 0.63. What is the ratio of the Balance of Payment (as % of service exports) in Honduras in 2009 to that in 2011?
Make the answer very short. 1.04. What is the ratio of the Balance of Payment (as % of service exports) of Malta in 2009 to that in 2011?
Make the answer very short. 1.32. What is the ratio of the Balance of Payment (as % of service exports) of Russian Federation in 2009 to that in 2011?
Give a very brief answer. 0.99. What is the ratio of the Balance of Payment (as % of service exports) in Cameroon in 2010 to that in 2011?
Provide a succinct answer. 0.8. What is the ratio of the Balance of Payment (as % of service exports) in Honduras in 2010 to that in 2011?
Provide a short and direct response. 0.97. What is the ratio of the Balance of Payment (as % of service exports) of Malta in 2010 to that in 2011?
Make the answer very short. 1.19. What is the ratio of the Balance of Payment (as % of service exports) of Russian Federation in 2010 to that in 2011?
Your answer should be very brief. 0.99. What is the difference between the highest and the second highest Balance of Payment (as % of service exports) in Cameroon?
Offer a very short reply. 0.55. What is the difference between the highest and the second highest Balance of Payment (as % of service exports) of Honduras?
Ensure brevity in your answer.  0.49. What is the difference between the highest and the second highest Balance of Payment (as % of service exports) of Malta?
Offer a terse response. 3.21. What is the difference between the highest and the second highest Balance of Payment (as % of service exports) in Russian Federation?
Make the answer very short. 0.16. What is the difference between the highest and the lowest Balance of Payment (as % of service exports) of Cameroon?
Give a very brief answer. 19.68. What is the difference between the highest and the lowest Balance of Payment (as % of service exports) of Honduras?
Offer a terse response. 3.22. What is the difference between the highest and the lowest Balance of Payment (as % of service exports) of Malta?
Your answer should be very brief. 8.37. What is the difference between the highest and the lowest Balance of Payment (as % of service exports) of Russian Federation?
Offer a very short reply. 5.77. 